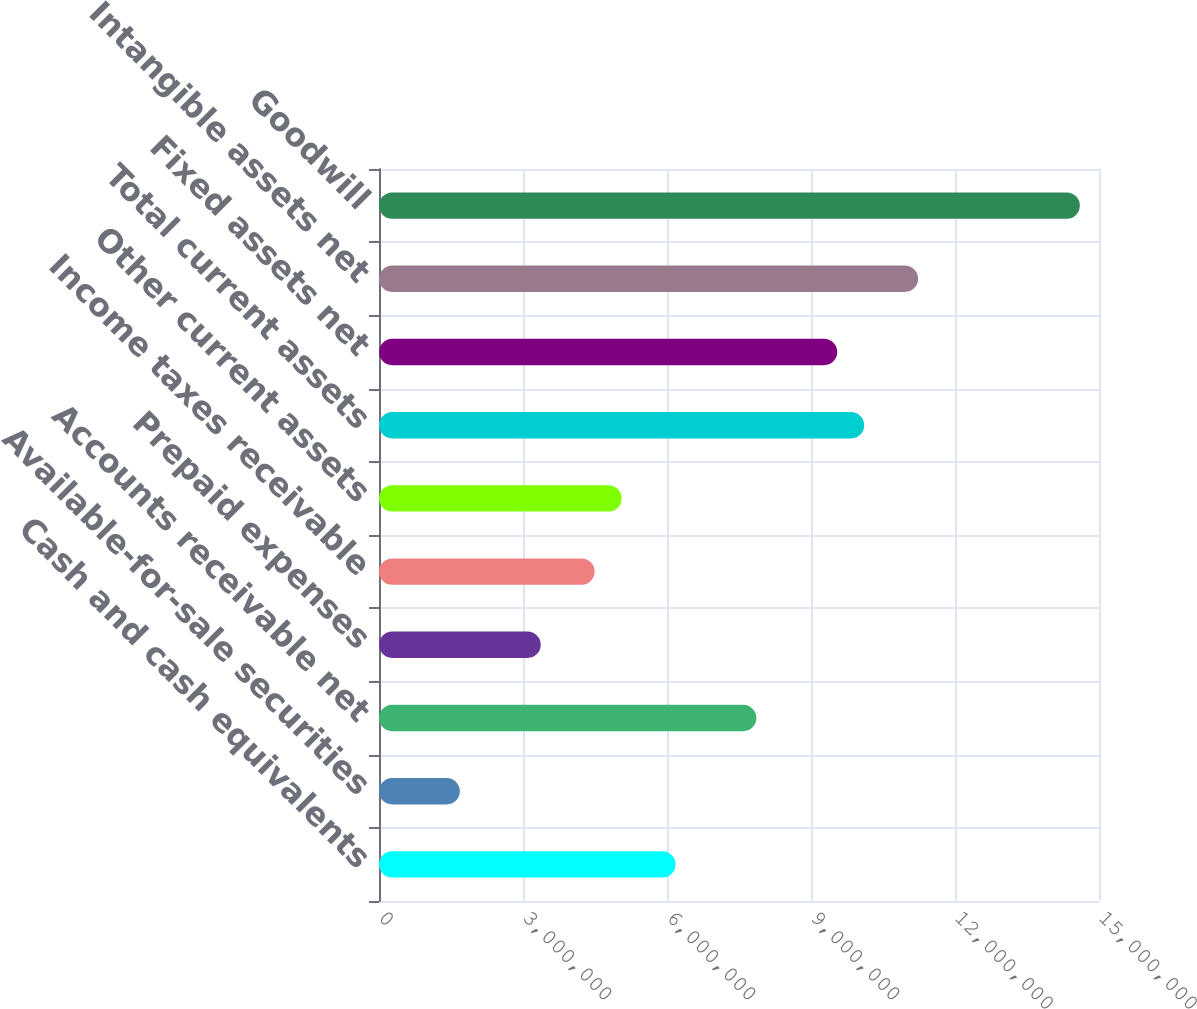<chart> <loc_0><loc_0><loc_500><loc_500><bar_chart><fcel>Cash and cash equivalents<fcel>Available-for-sale securities<fcel>Accounts receivable net<fcel>Prepaid expenses<fcel>Income taxes receivable<fcel>Other current assets<fcel>Total current assets<fcel>Fixed assets net<fcel>Intangible assets net<fcel>Goodwill<nl><fcel>6.17751e+06<fcel>1.68487e+06<fcel>7.86224e+06<fcel>3.36961e+06<fcel>4.49277e+06<fcel>5.05435e+06<fcel>1.01086e+07<fcel>9.54698e+06<fcel>1.12317e+07<fcel>1.46012e+07<nl></chart> 